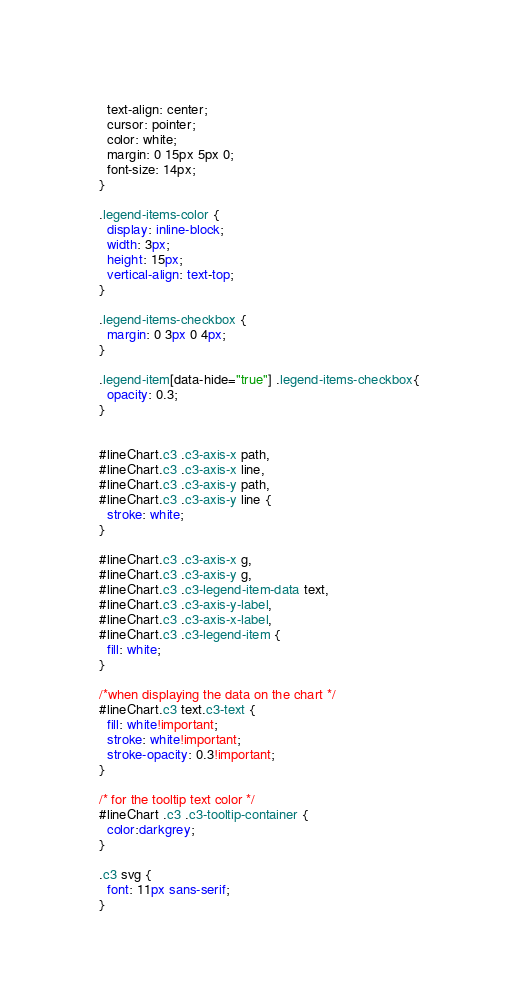<code> <loc_0><loc_0><loc_500><loc_500><_CSS_>  text-align: center;
  cursor: pointer;
  color: white;
  margin: 0 15px 5px 0;
  font-size: 14px;
}

.legend-items-color {
  display: inline-block;
  width: 3px;
  height: 15px;
  vertical-align: text-top;
}

.legend-items-checkbox {
  margin: 0 3px 0 4px;
}

.legend-item[data-hide="true"] .legend-items-checkbox{
  opacity: 0.3;
}


#lineChart.c3 .c3-axis-x path,
#lineChart.c3 .c3-axis-x line,
#lineChart.c3 .c3-axis-y path,
#lineChart.c3 .c3-axis-y line {
  stroke: white;
}

#lineChart.c3 .c3-axis-x g,
#lineChart.c3 .c3-axis-y g,
#lineChart.c3 .c3-legend-item-data text,
#lineChart.c3 .c3-axis-y-label,
#lineChart.c3 .c3-axis-x-label,
#lineChart.c3 .c3-legend-item {
  fill: white;
}

/*when displaying the data on the chart */
#lineChart.c3 text.c3-text { 
  fill: white!important;
  stroke: white!important;
  stroke-opacity: 0.3!important;
}

/* for the tooltip text color */
#lineChart .c3 .c3-tooltip-container {
  color:darkgrey;
}

.c3 svg {
  font: 11px sans-serif;
}</code> 